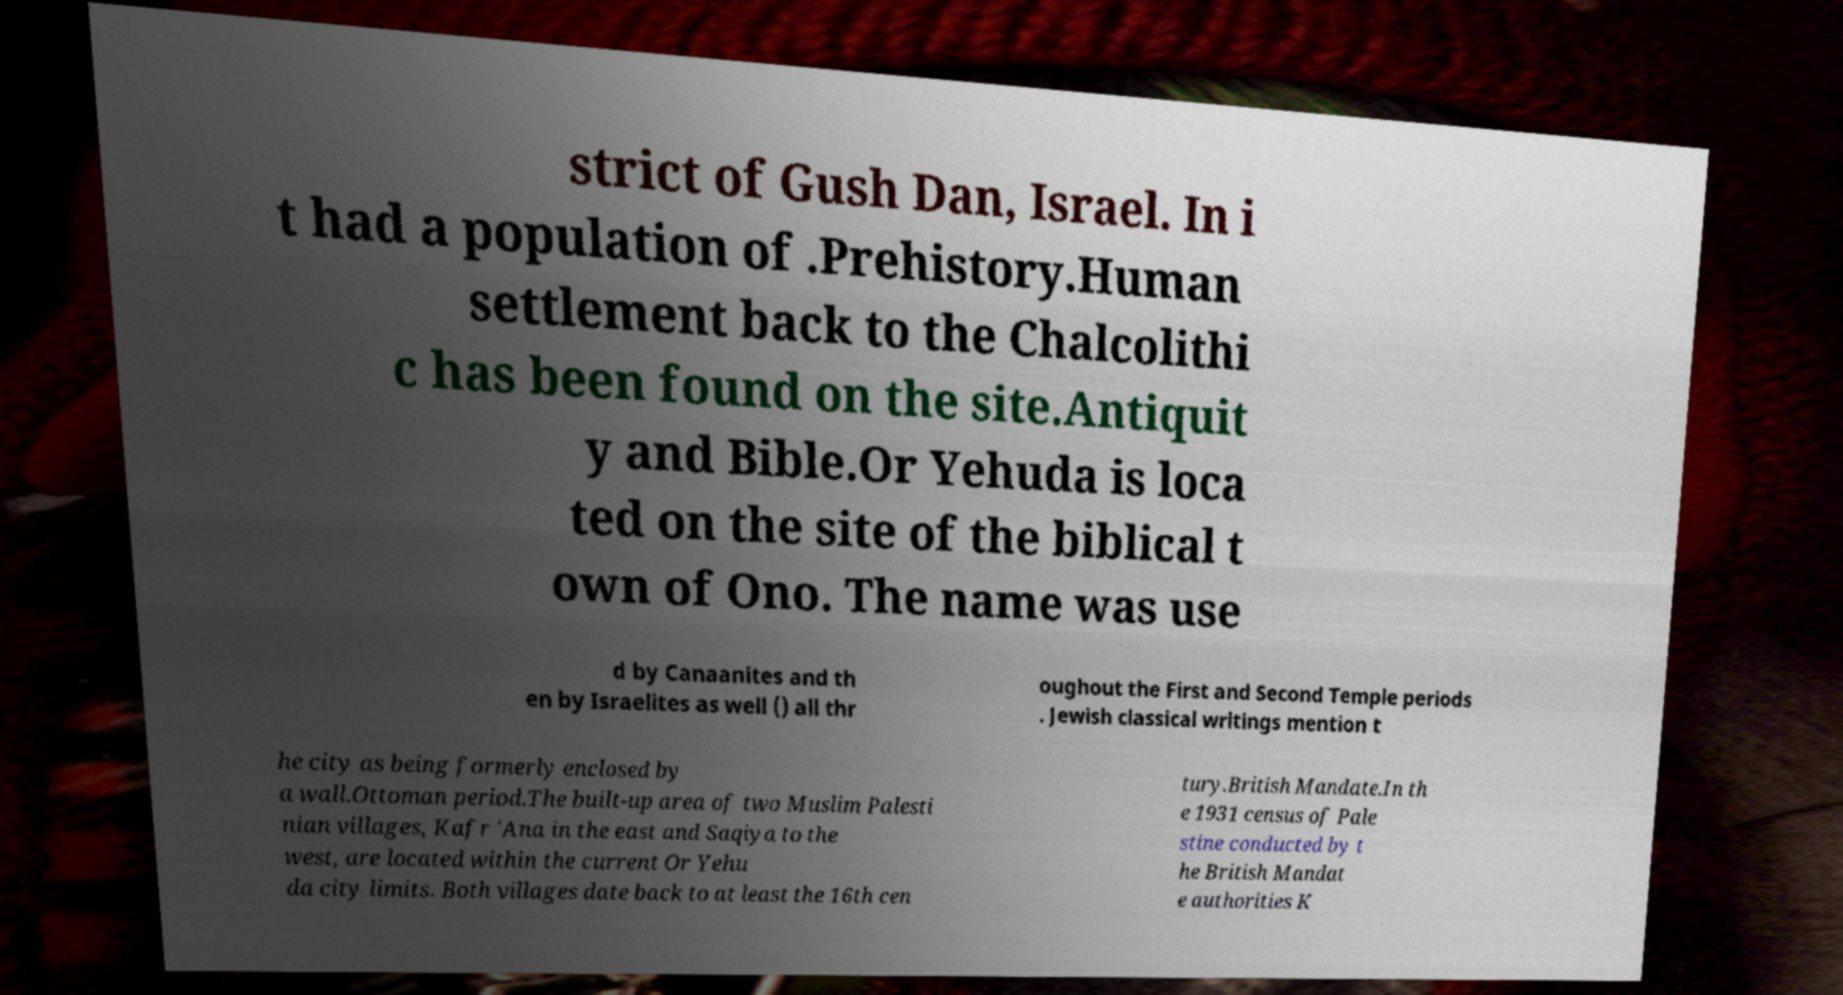I need the written content from this picture converted into text. Can you do that? strict of Gush Dan, Israel. In i t had a population of .Prehistory.Human settlement back to the Chalcolithi c has been found on the site.Antiquit y and Bible.Or Yehuda is loca ted on the site of the biblical t own of Ono. The name was use d by Canaanites and th en by Israelites as well () all thr oughout the First and Second Temple periods . Jewish classical writings mention t he city as being formerly enclosed by a wall.Ottoman period.The built-up area of two Muslim Palesti nian villages, Kafr 'Ana in the east and Saqiya to the west, are located within the current Or Yehu da city limits. Both villages date back to at least the 16th cen tury.British Mandate.In th e 1931 census of Pale stine conducted by t he British Mandat e authorities K 